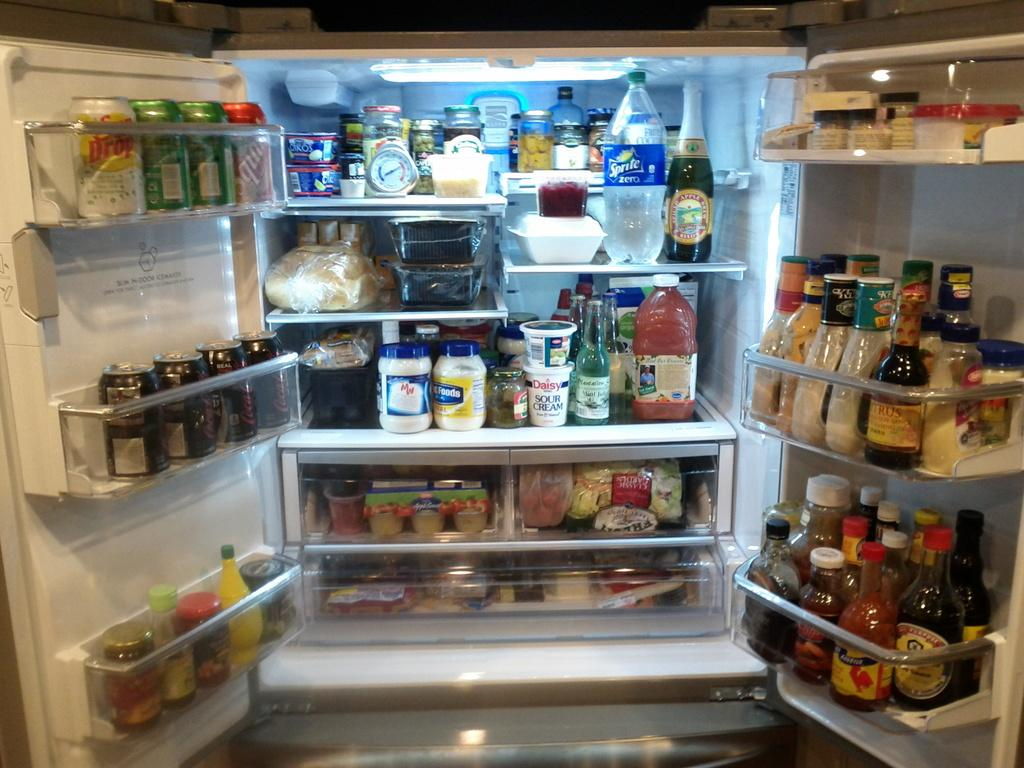What types of containers can be seen in the refrigerator in the image? There are bottles, jars, tins, and plastic covers in the refrigerator. What else can be found in the refrigerator besides containers? There are bowls and food items in the refrigerator. What type of mint is growing on the butter in the image? There is no mint or butter present in the image; the image only shows items inside a refrigerator. 